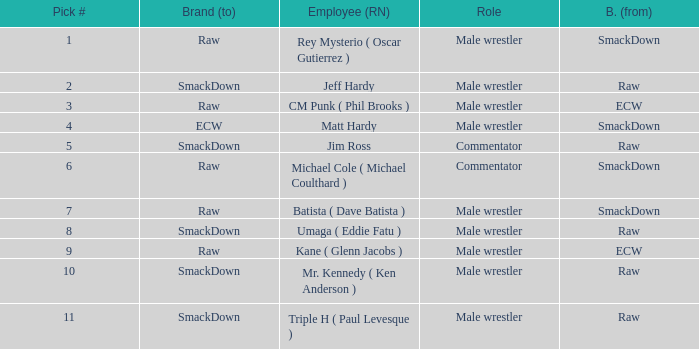What position did pick #10 play? Male wrestler. 